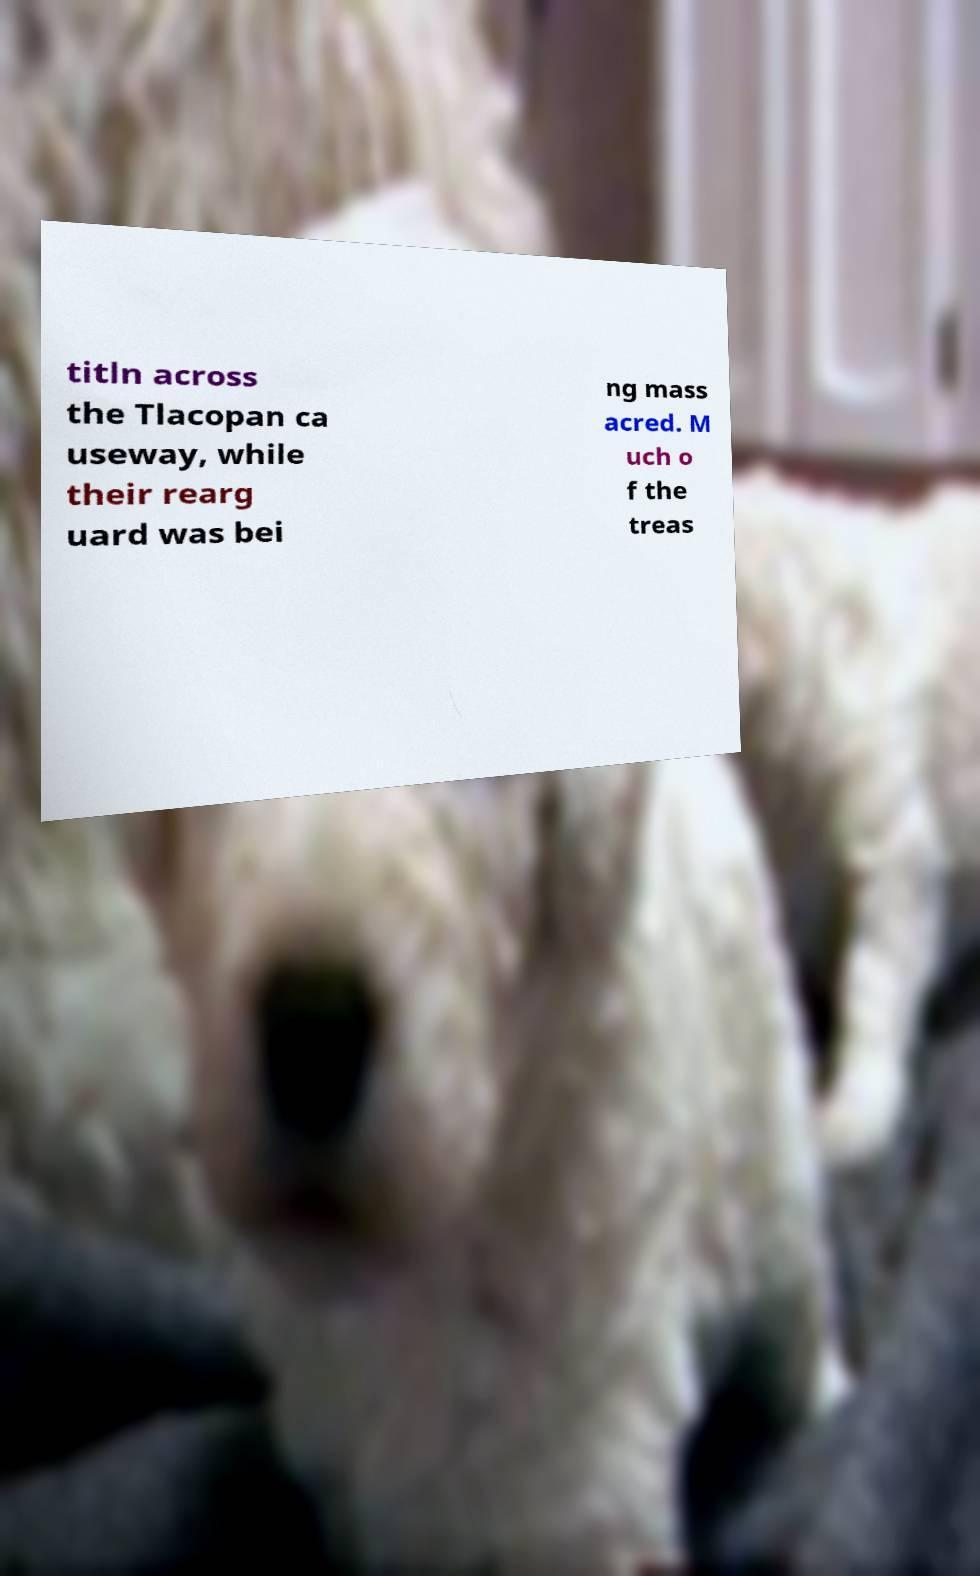I need the written content from this picture converted into text. Can you do that? titln across the Tlacopan ca useway, while their rearg uard was bei ng mass acred. M uch o f the treas 